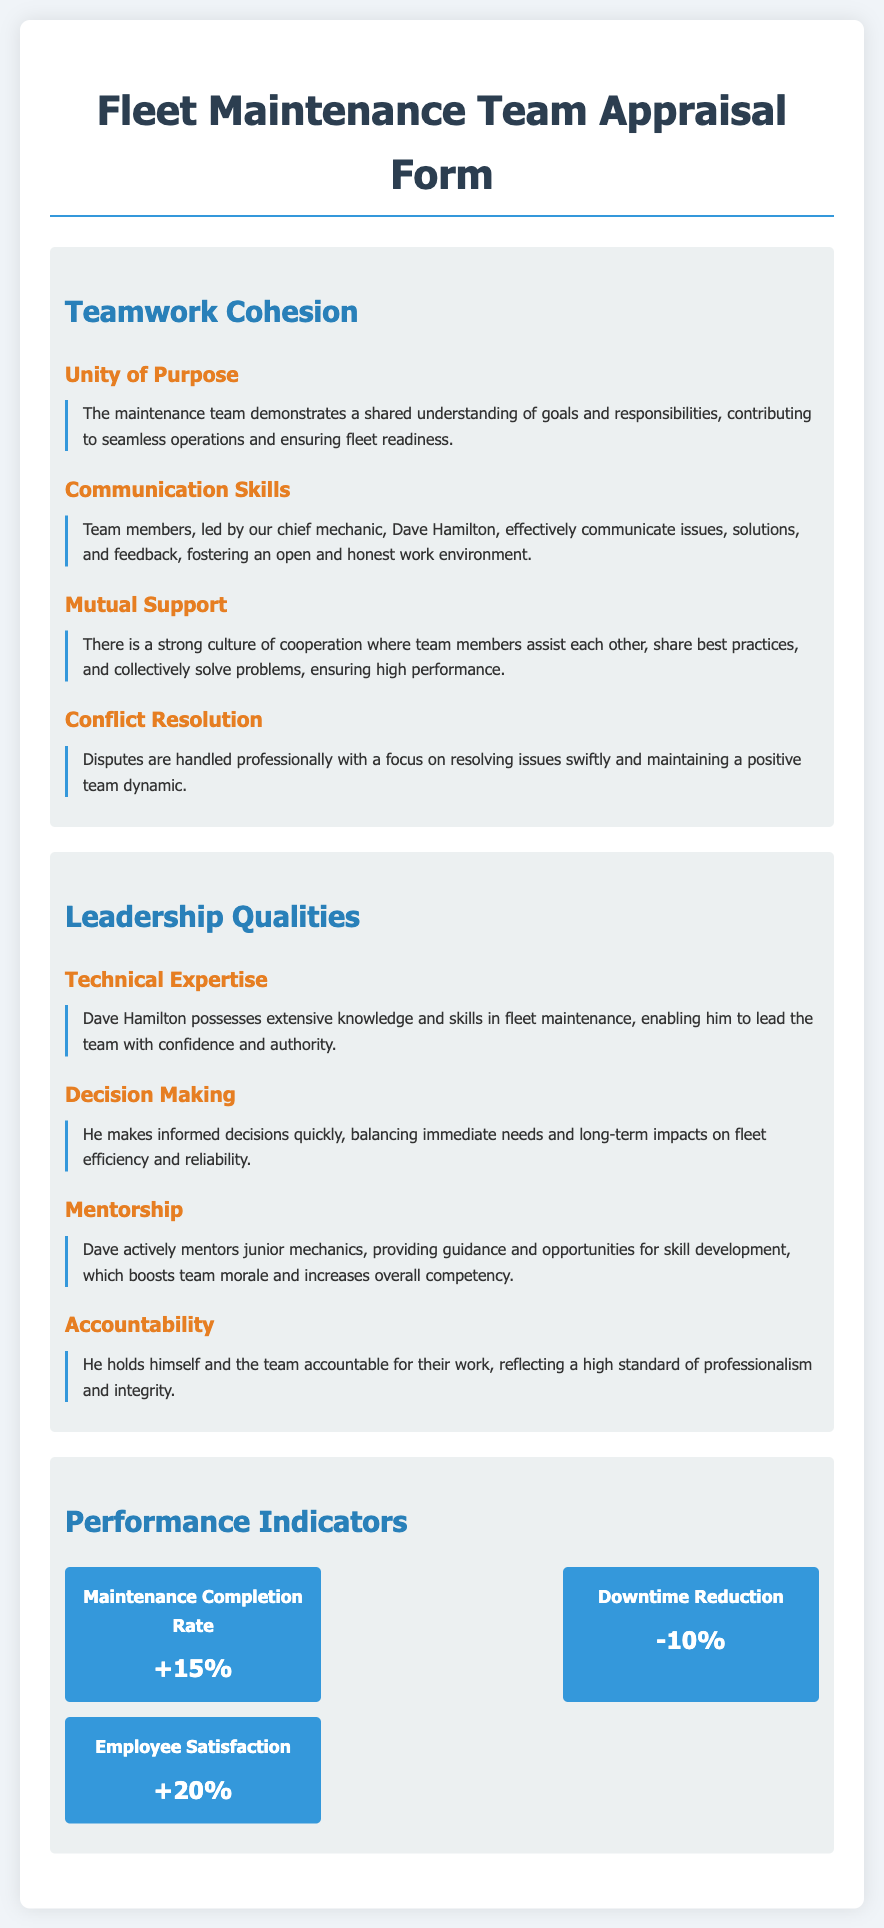What is the name of the chief mechanic? The chief mechanic's name is mentioned in the document as Dave Hamilton.
Answer: Dave Hamilton What is the percentage increase in maintenance completion rate? The document states that the maintenance completion rate increased by 15 percent.
Answer: +15% What is the percentage decrease in downtime? The appraisal form indicates a reduction in downtime by 10 percent.
Answer: -10% What does the team demonstrate according to the 'Unity of Purpose' subsection? The text describes the maintenance team as having a shared understanding of goals and responsibilities.
Answer: Shared understanding How does Dave Hamilton positively influence junior mechanics? He actively provides guidance and opportunities for skill development to junior mechanics.
Answer: Mentorship How does the team handle disputes according to the document? The document mentions that disputes are handled professionally with a focus on resolution.
Answer: Professionally What is the reported increase in employee satisfaction? According to the performance indicators, employee satisfaction has increased by 20 percent.
Answer: +20% What is highlighted as a significant leadership quality of Dave Hamilton? Technical expertise is noted as one of the significant leadership qualities of Dave Hamilton.
Answer: Technical expertise What is the overall theme of the 'Teamwork Cohesion' section? The overall theme highlights aspects of unity within the maintenance team, such as support and communication.
Answer: Unity of purpose 